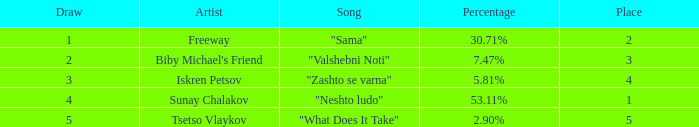In a situation where the place is below 3 and the percentage equals 30.71%, what is the highest draw? 1.0. 